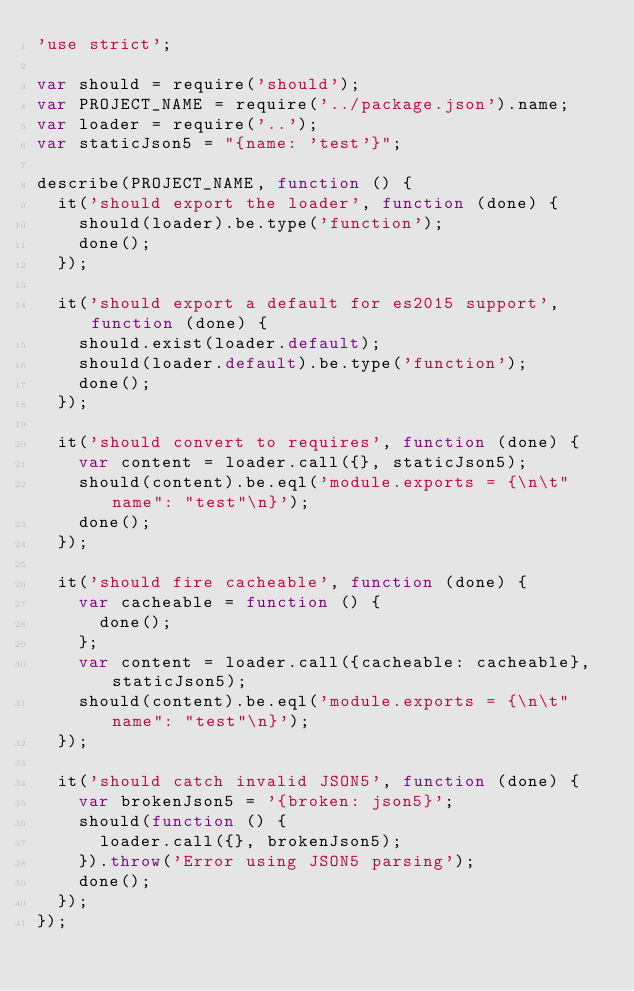Convert code to text. <code><loc_0><loc_0><loc_500><loc_500><_JavaScript_>'use strict';

var should = require('should');
var PROJECT_NAME = require('../package.json').name;
var loader = require('..');
var staticJson5 = "{name: 'test'}";

describe(PROJECT_NAME, function () {
  it('should export the loader', function (done) {
    should(loader).be.type('function');
    done();
  });

  it('should export a default for es2015 support', function (done) {
    should.exist(loader.default);
    should(loader.default).be.type('function');
    done();
  });

  it('should convert to requires', function (done) {
    var content = loader.call({}, staticJson5);
    should(content).be.eql('module.exports = {\n\t"name": "test"\n}');
    done();
  });

  it('should fire cacheable', function (done) {
    var cacheable = function () {
      done();
    };
    var content = loader.call({cacheable: cacheable}, staticJson5);
    should(content).be.eql('module.exports = {\n\t"name": "test"\n}');
  });

  it('should catch invalid JSON5', function (done) {
    var brokenJson5 = '{broken: json5}';
    should(function () {
      loader.call({}, brokenJson5);
    }).throw('Error using JSON5 parsing');
    done();
  });
});
</code> 